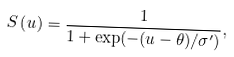Convert formula to latex. <formula><loc_0><loc_0><loc_500><loc_500>S \left ( u \right ) = \frac { 1 } { 1 + \exp ( - ( u - \theta ) / \sigma ^ { \prime } ) } ,</formula> 